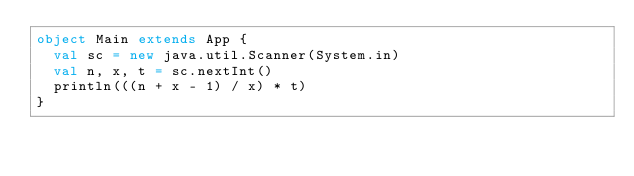<code> <loc_0><loc_0><loc_500><loc_500><_Scala_>object Main extends App {
  val sc = new java.util.Scanner(System.in)
  val n, x, t = sc.nextInt()
  println(((n + x - 1) / x) * t)
}
</code> 